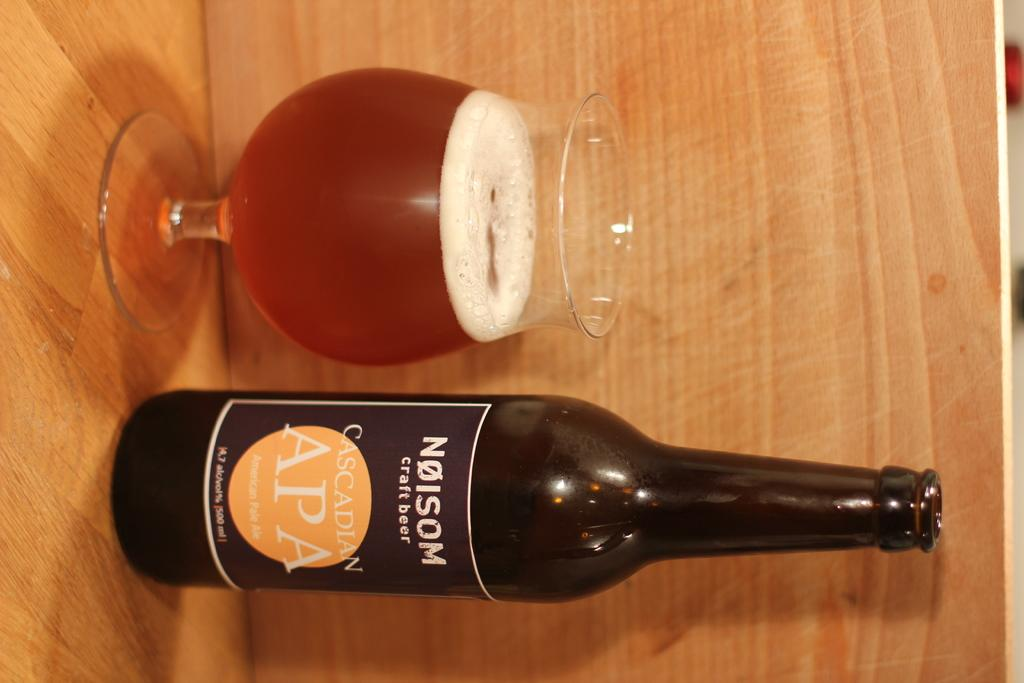<image>
Share a concise interpretation of the image provided. A bottle of Cascadian APA sits next to a full glass. 